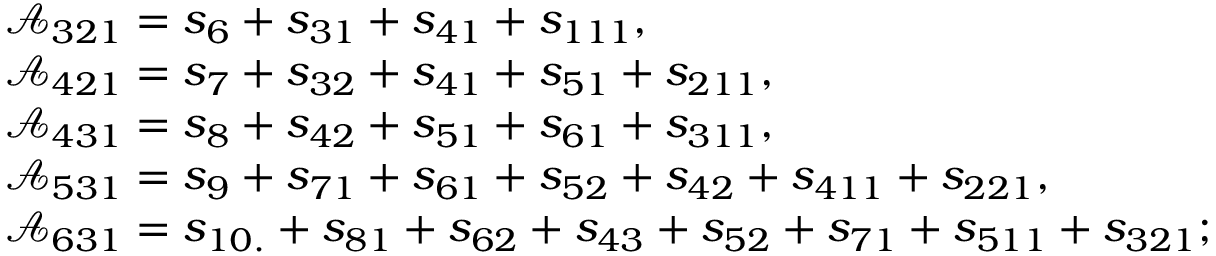<formula> <loc_0><loc_0><loc_500><loc_500>\begin{array} { r l } & { \mathcal { A } _ { 3 2 1 } = s _ { 6 } + s _ { 3 1 } + s _ { 4 1 } + s _ { 1 1 1 } , } \\ & { \mathcal { A } _ { 4 2 1 } = s _ { 7 } + s _ { 3 2 } + s _ { 4 1 } + s _ { 5 1 } + s _ { 2 1 1 } , } \\ & { \mathcal { A } _ { 4 3 1 } = s _ { 8 } + s _ { 4 2 } + s _ { 5 1 } + s _ { 6 1 } + s _ { 3 1 1 } , } \\ & { \mathcal { A } _ { 5 3 1 } = s _ { 9 } + s _ { 7 1 } + s _ { 6 1 } + s _ { 5 2 } + s _ { 4 2 } + s _ { 4 1 1 } + s _ { 2 2 1 } , } \\ & { \mathcal { A } _ { 6 3 1 } = s _ { 1 0 . } + s _ { 8 1 } + s _ { 6 2 } + s _ { 4 3 } + s _ { 5 2 } + s _ { 7 1 } + s _ { 5 1 1 } + s _ { 3 2 1 } ; } \end{array}</formula> 